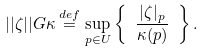<formula> <loc_0><loc_0><loc_500><loc_500>| | \zeta | | G \kappa \stackrel { d e f } { = } \sup _ { p \in U } \left \{ \ \frac { | \zeta | _ { p } } { \kappa ( p ) } \ \right \} .</formula> 